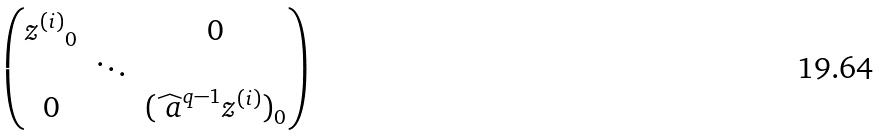<formula> <loc_0><loc_0><loc_500><loc_500>\begin{pmatrix} { z ^ { ( i ) } } _ { 0 } & & 0 \\ & \ddots & \\ 0 & & ( \widehat { \ a } ^ { q - 1 } { z ^ { ( i ) } ) } _ { 0 } \end{pmatrix}</formula> 